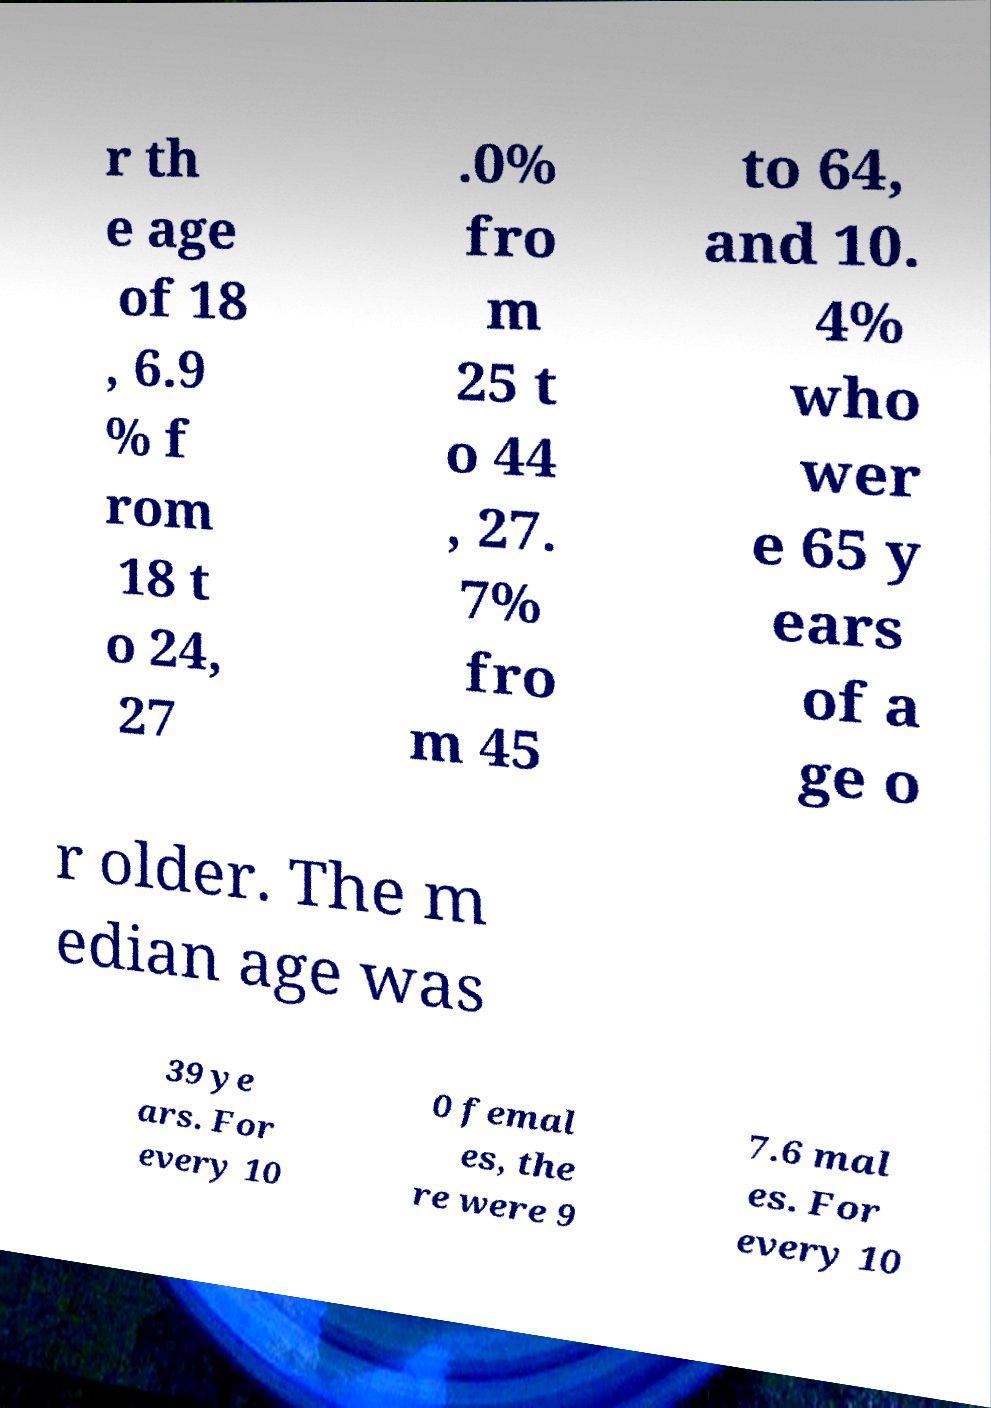For documentation purposes, I need the text within this image transcribed. Could you provide that? r th e age of 18 , 6.9 % f rom 18 t o 24, 27 .0% fro m 25 t o 44 , 27. 7% fro m 45 to 64, and 10. 4% who wer e 65 y ears of a ge o r older. The m edian age was 39 ye ars. For every 10 0 femal es, the re were 9 7.6 mal es. For every 10 